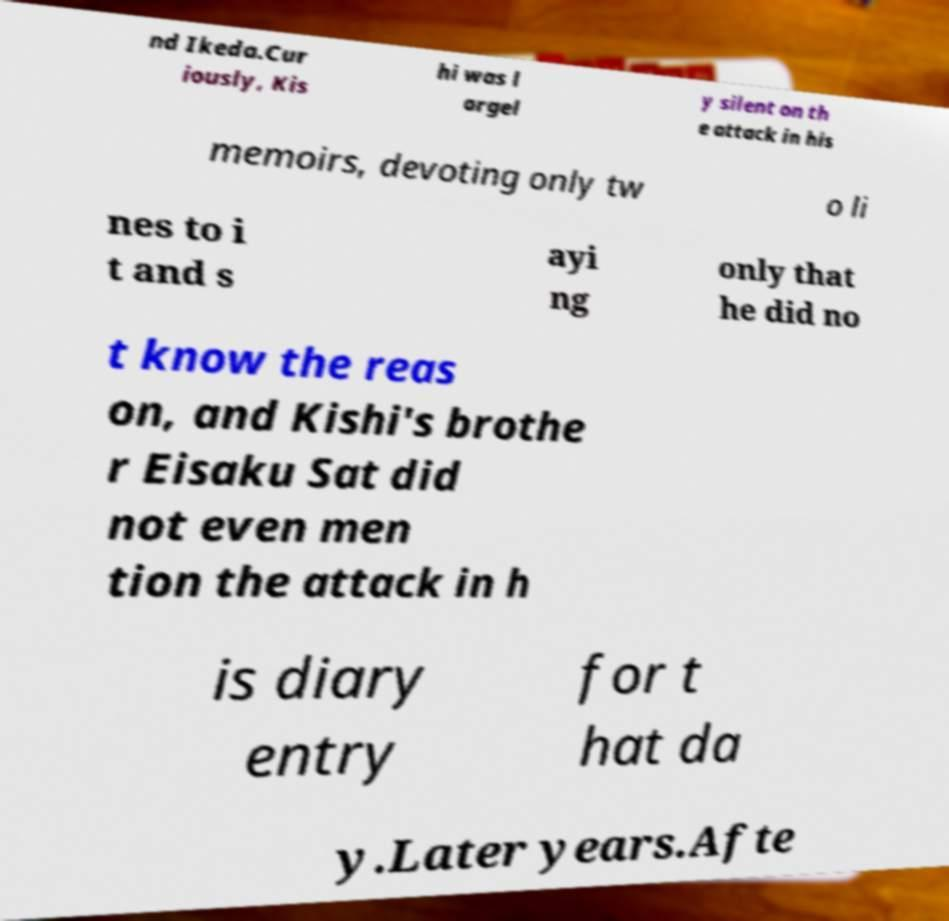There's text embedded in this image that I need extracted. Can you transcribe it verbatim? nd Ikeda.Cur iously, Kis hi was l argel y silent on th e attack in his memoirs, devoting only tw o li nes to i t and s ayi ng only that he did no t know the reas on, and Kishi's brothe r Eisaku Sat did not even men tion the attack in h is diary entry for t hat da y.Later years.Afte 